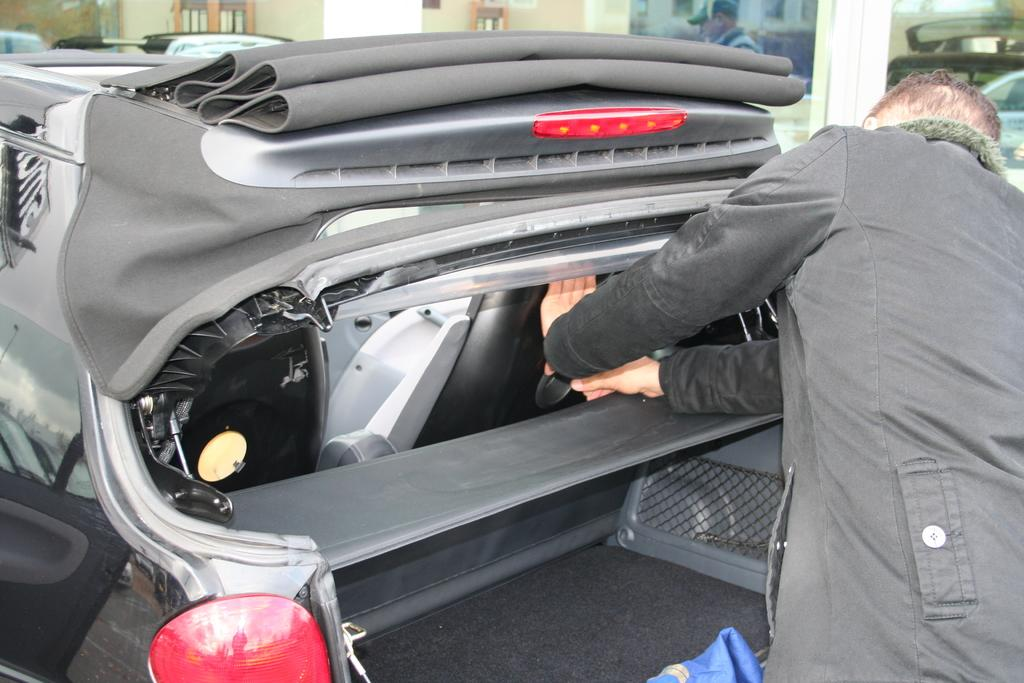What is the main subject of the image? There is a person near a car in the image. Can you describe the surroundings of the person? There are other cars visible in the background of the image. Are there any other people in the image? Yes, there is another person in the background of the image. What route is the actor taking in the image? There is no actor present in the image, and no route is mentioned or depicted. 